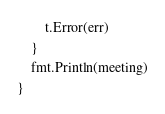<code> <loc_0><loc_0><loc_500><loc_500><_Go_>		t.Error(err)
	}
	fmt.Println(meeting)
}
</code> 